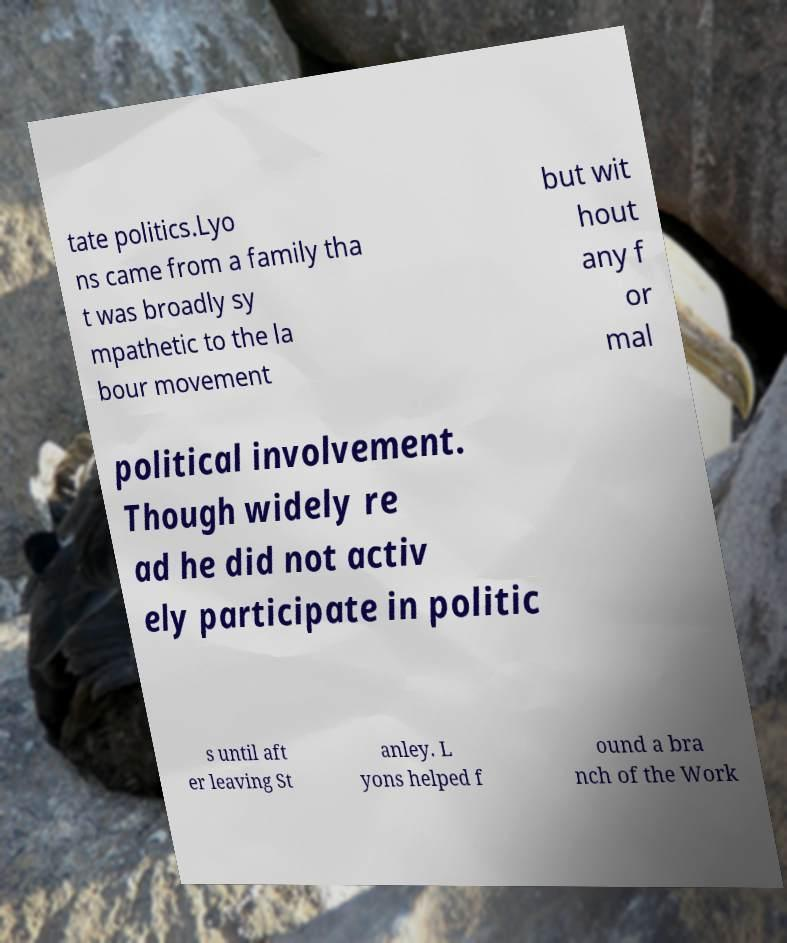Could you extract and type out the text from this image? tate politics.Lyo ns came from a family tha t was broadly sy mpathetic to the la bour movement but wit hout any f or mal political involvement. Though widely re ad he did not activ ely participate in politic s until aft er leaving St anley. L yons helped f ound a bra nch of the Work 